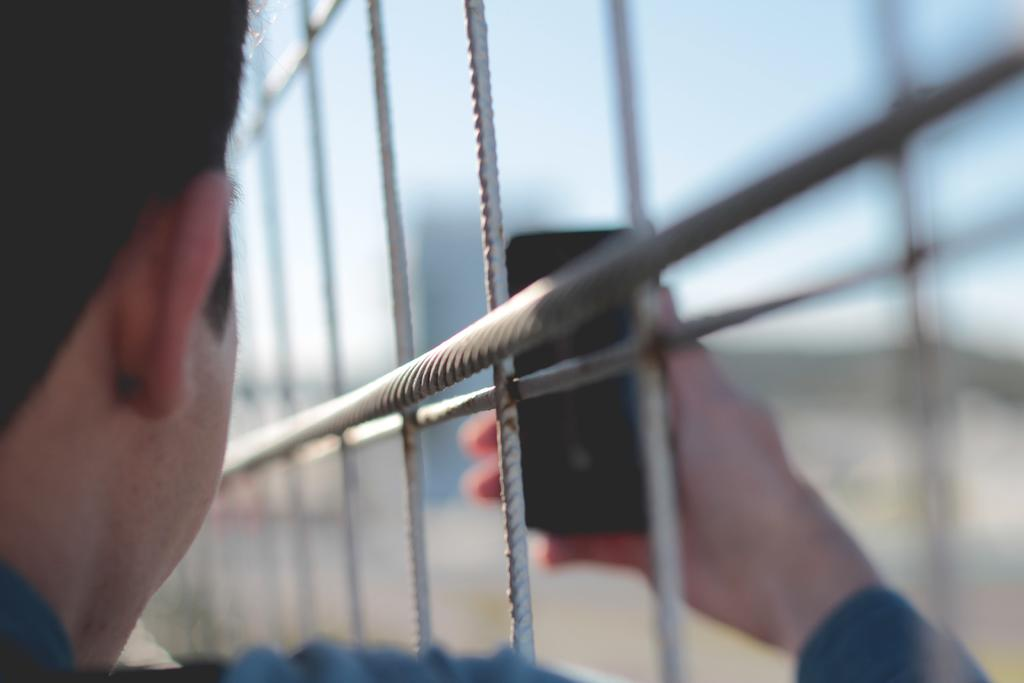Who is present in the image? There is a man in the image. What is the man holding in his hand? The man is holding a mobile in his hand. What type of barrier can be seen in the image? There is a metal fence in the image. Can you describe the background of the image? The background of the image is blurry. Are there any representatives or parents visible in the image? There is no mention of representatives or parents in the image; it only features a man holding a mobile and a metal fence in the background. 